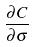Convert formula to latex. <formula><loc_0><loc_0><loc_500><loc_500>\frac { \partial C } { \partial \sigma }</formula> 